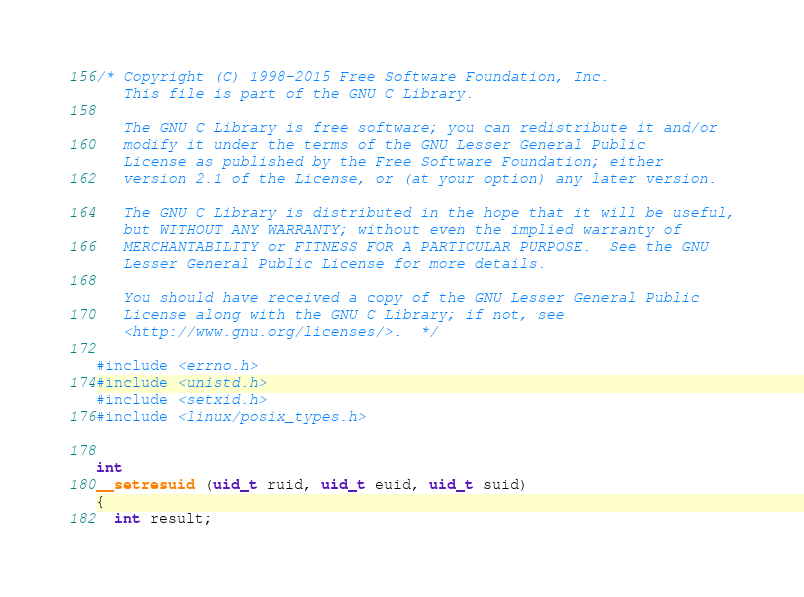Convert code to text. <code><loc_0><loc_0><loc_500><loc_500><_C_>/* Copyright (C) 1998-2015 Free Software Foundation, Inc.
   This file is part of the GNU C Library.

   The GNU C Library is free software; you can redistribute it and/or
   modify it under the terms of the GNU Lesser General Public
   License as published by the Free Software Foundation; either
   version 2.1 of the License, or (at your option) any later version.

   The GNU C Library is distributed in the hope that it will be useful,
   but WITHOUT ANY WARRANTY; without even the implied warranty of
   MERCHANTABILITY or FITNESS FOR A PARTICULAR PURPOSE.  See the GNU
   Lesser General Public License for more details.

   You should have received a copy of the GNU Lesser General Public
   License along with the GNU C Library; if not, see
   <http://www.gnu.org/licenses/>.  */

#include <errno.h>
#include <unistd.h>
#include <setxid.h>
#include <linux/posix_types.h>


int
__setresuid (uid_t ruid, uid_t euid, uid_t suid)
{
  int result;
</code> 